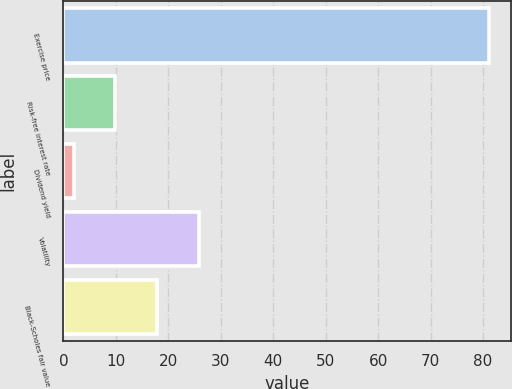<chart> <loc_0><loc_0><loc_500><loc_500><bar_chart><fcel>Exercise price<fcel>Risk-free interest rate<fcel>Dividend yield<fcel>Volatility<fcel>Black-Scholes fair value<nl><fcel>81.19<fcel>9.92<fcel>2<fcel>25.76<fcel>17.84<nl></chart> 